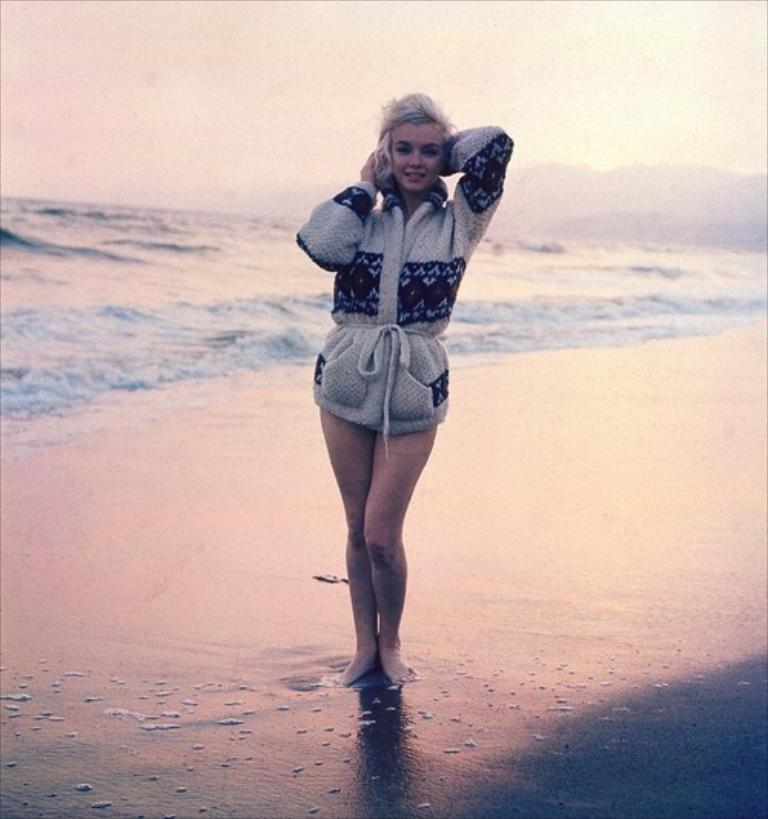What is the main element present in the image? There is water in the image. Can you describe the person in the image? There is a girl standing in the front of the image. What can be seen in the background of the image? The sky is visible in the image. What type of pencil is the girl holding in the image? There is no pencil present in the image. What is the girl's reaction to the water in the image? The image does not show the girl's reaction to the water, so it cannot be determined. 